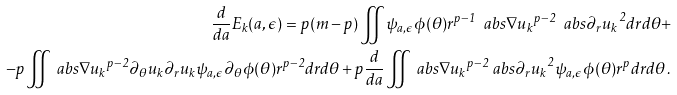Convert formula to latex. <formula><loc_0><loc_0><loc_500><loc_500>\frac { d } { d a } E _ { k } ( a , \epsilon ) = p ( m - p ) \iint \psi _ { a , \epsilon } \phi ( \theta ) r ^ { p - 1 } \ a b s { \nabla u _ { k } } ^ { p - 2 } \ a b s { \partial _ { r } u _ { k } } ^ { 2 } d r d \theta + \\ - p \iint \ a b s { \nabla u _ { k } } ^ { p - 2 } \partial _ { \theta } u _ { k } \partial _ { r } u _ { k } \psi _ { a , \epsilon } \partial _ { \theta } \phi ( \theta ) r ^ { p - 2 } d r d \theta + p \frac { d } { d a } \iint \ a b s { \nabla u _ { k } } ^ { p - 2 } \ a b s { \partial _ { r } u _ { k } } ^ { 2 } \psi _ { a , \epsilon } \phi ( \theta ) r ^ { p } d r d \theta \, .</formula> 